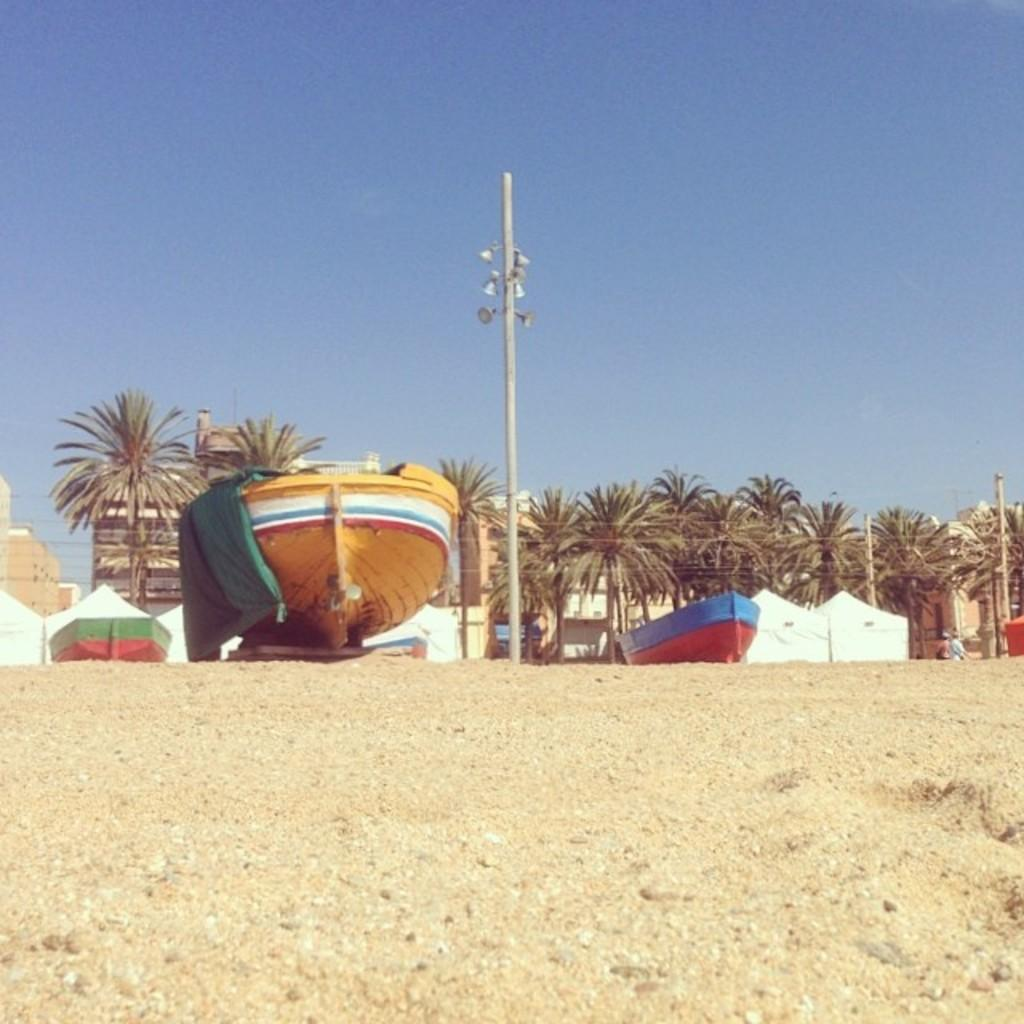What part of the natural environment is visible in the image? The sky is visible in the image. What type of vegetation can be seen in the image? There are trees in the image. What type of watercraft is present in the image? There are boats in the image. What is the tall, vertical object in the image? There is a pole in the image. What type of bells can be heard ringing in the image? There are no bells present in the image, and therefore no sound can be heard. What is the aftermath of the event depicted in the image? There is no event depicted in the image, so there is no aftermath to describe. 